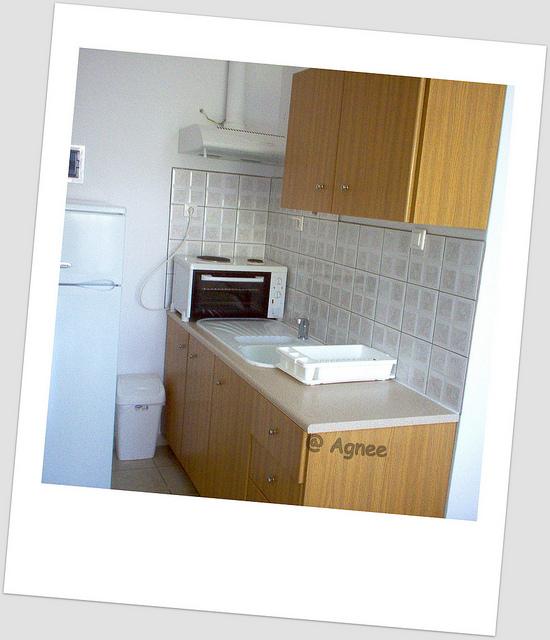What can you put in the oven?
Answer briefly. Food. What type of air conditioner is there?
Quick response, please. None. Is there a garbage can in this kitchen?
Answer briefly. Yes. What's on the counter?
Short answer required. Microwave. 